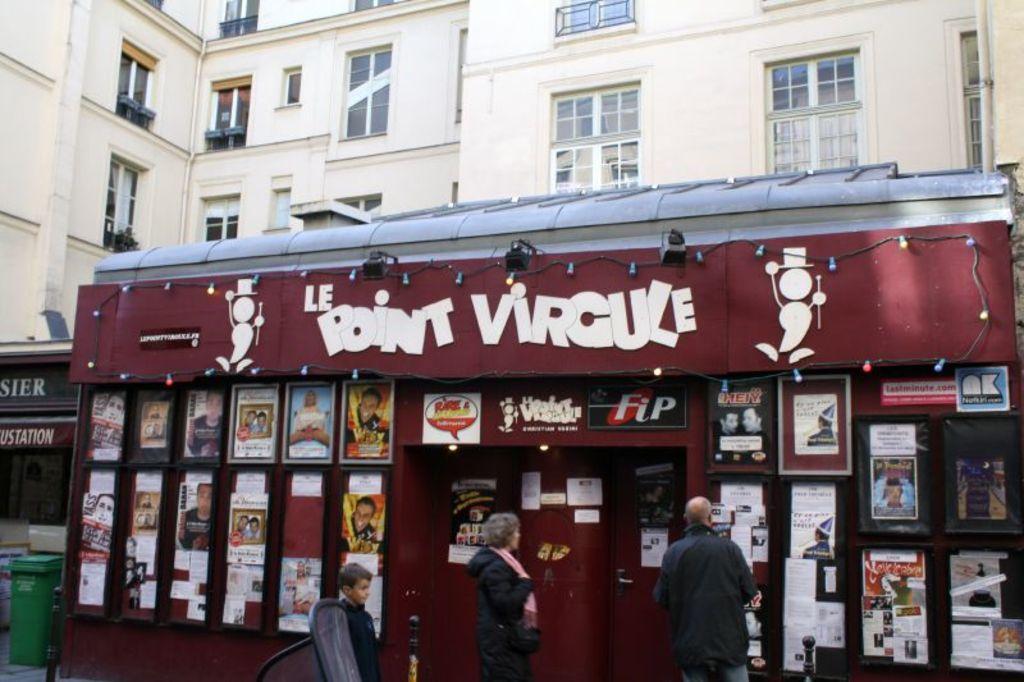Describe this image in one or two sentences. In this image, there are two persons wearing clothes and standing in front of the stall. There is a building at the top of the image. There is a trash bin in the bottom left of the image. 